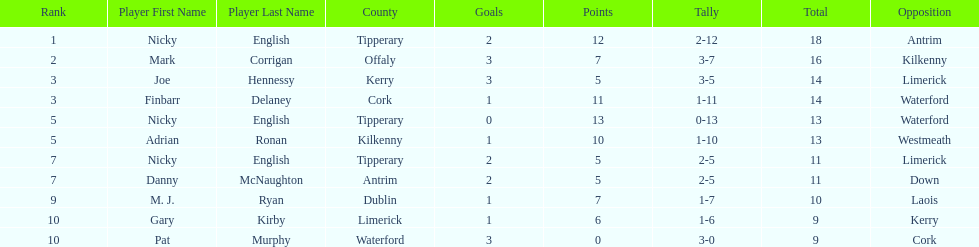What is the first name on the list? Nicky English. 